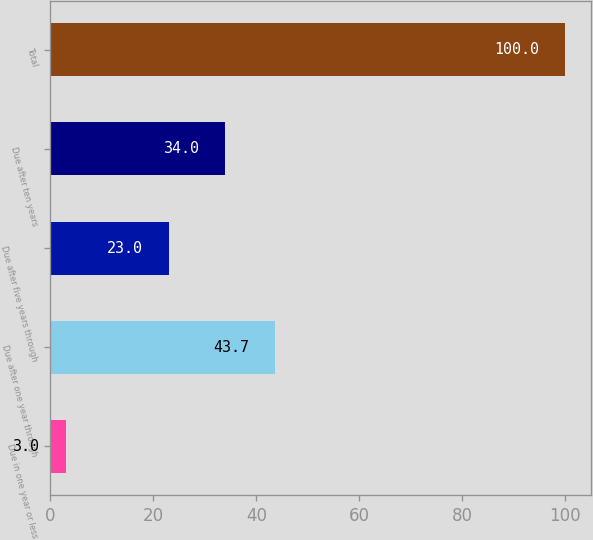Convert chart to OTSL. <chart><loc_0><loc_0><loc_500><loc_500><bar_chart><fcel>Due in one year or less<fcel>Due after one year through<fcel>Due after five years through<fcel>Due after ten years<fcel>Total<nl><fcel>3<fcel>43.7<fcel>23<fcel>34<fcel>100<nl></chart> 